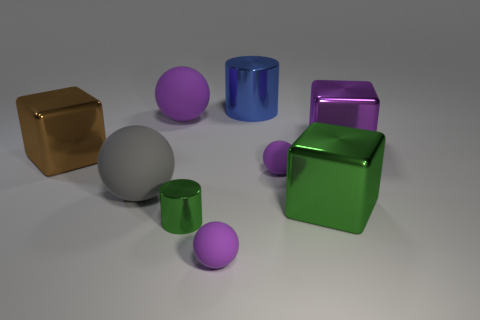There is a block that is to the left of the tiny rubber ball behind the green shiny cylinder; how many brown blocks are left of it?
Give a very brief answer. 0. Is there another metal cube that has the same size as the purple metal block?
Your answer should be compact. Yes. Is the number of big objects to the left of the tiny metal object less than the number of large purple blocks?
Ensure brevity in your answer.  No. There is a cylinder that is behind the purple matte object that is on the right side of the matte ball in front of the green metallic cube; what is it made of?
Make the answer very short. Metal. Are there more small shiny cylinders behind the tiny green metal cylinder than green cubes that are behind the purple shiny cube?
Keep it short and to the point. No. What number of rubber things are large purple objects or big brown things?
Keep it short and to the point. 1. There is a thing that is the same color as the tiny cylinder; what shape is it?
Provide a succinct answer. Cube. What is the material of the brown block in front of the purple metal thing?
Your response must be concise. Metal. What number of objects are tiny green cylinders or big shiny things behind the big purple shiny block?
Ensure brevity in your answer.  2. There is a purple metal object that is the same size as the green shiny cube; what shape is it?
Keep it short and to the point. Cube. 